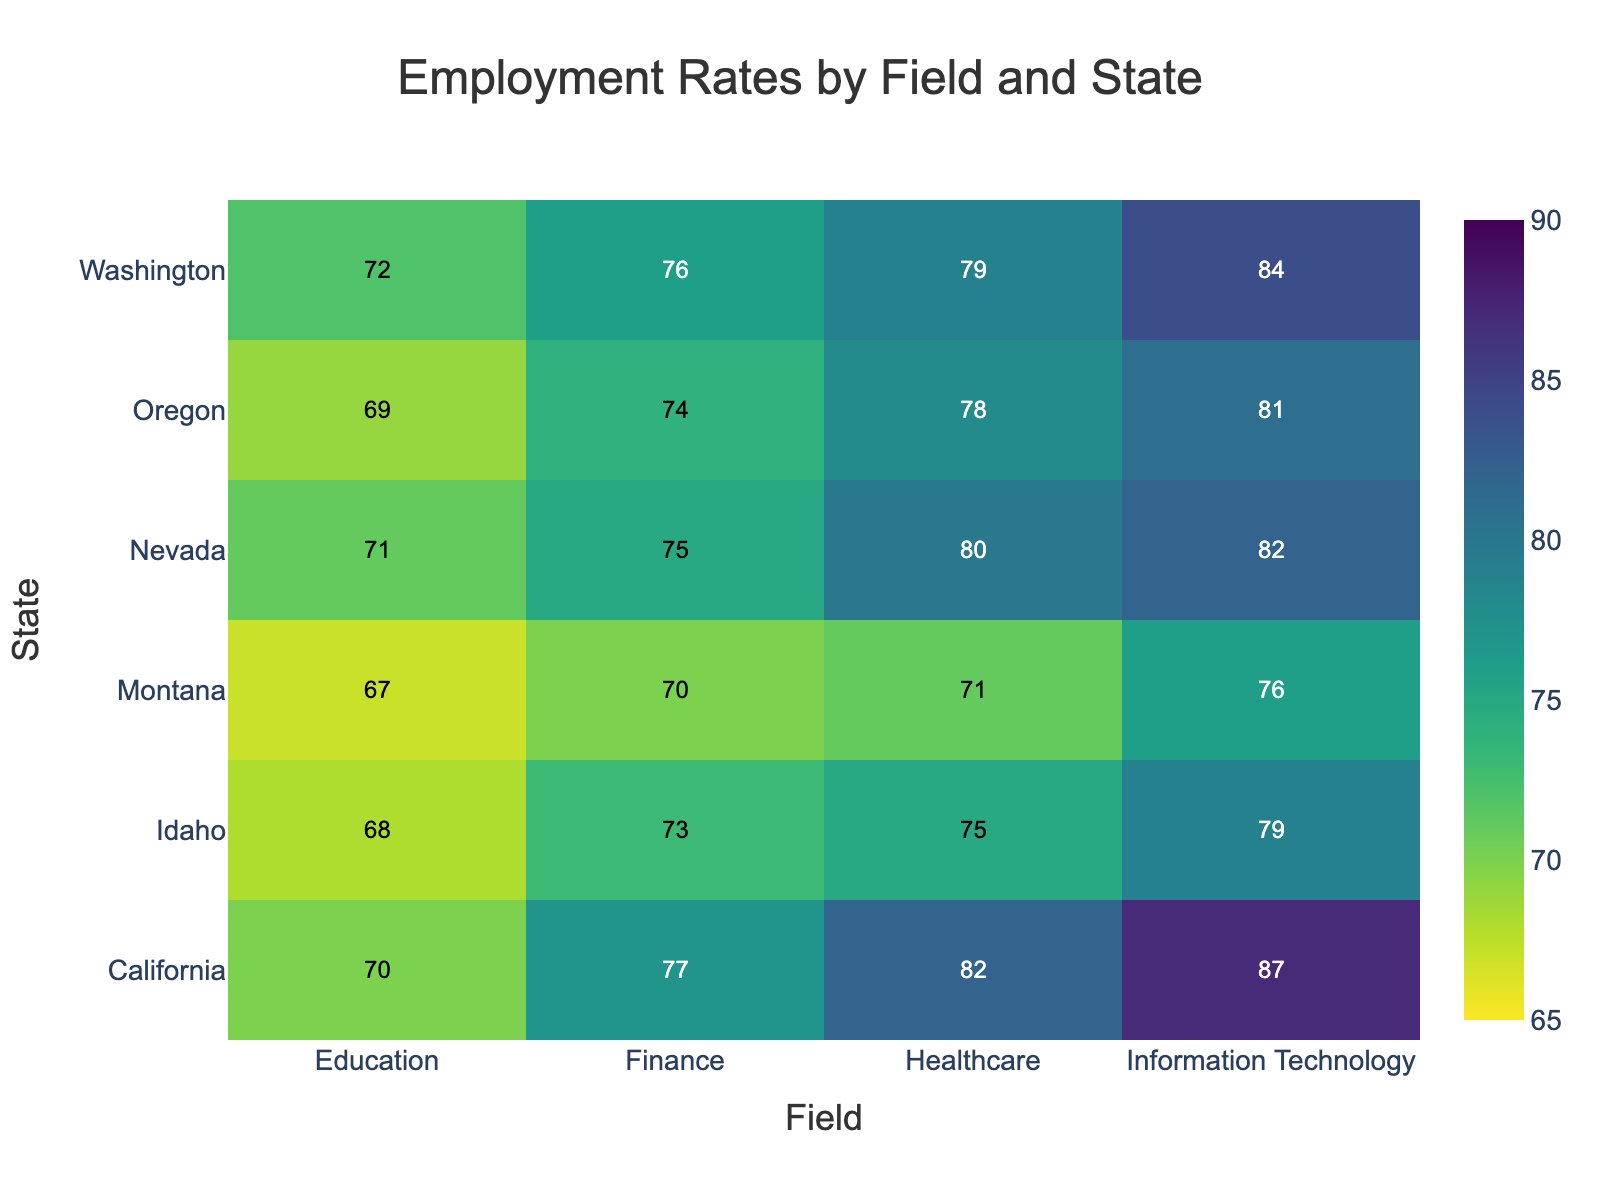What's the employment rate in Information Technology in Washington? Look for Washington on the y-axis and Information Technology on the x-axis. The cell where they intersect will give the employment rate.
Answer: 84% Which state has the highest employment rate in Healthcare? Compare the employment rates in Healthcare across all states. Find the highest rate.
Answer: California What is the difference in employment rates between Information Technology and Education in California? Identify the employment rates in California for Information Technology and Education. Subtract the employment rate of Education from that of Information Technology.
Answer: 17% What is the median employment rate for Education among all states? List out all the employment rates for Education. Sort them and find the median (the middle value). The values are 67, 68, 69, 70, 71, 72. Median is the average of the two middle values: (69+70)/2.
Answer: 69.5% Which field has the most consistent employment rates across all states? Evaluate the range (difference between the maximum and minimum employment rates) for each field across states. The field with the smallest range is the most consistent. Information Technology: range = 87-76 = 11 Healthcare: range = 82-71 = 11 Education: range = 72-67 = 5 Finance: range = 77-70 = 7
Answer: Education Are there any fields where all states have an employment rate above 70%? Check each field's employment rate across all states to see if they are all above 70%. Information Technology: All above 70% Healthcare: All above 70% Education: Montana and Idaho have values below 70% Finance: All above 70%
Answer: Information Technology, Healthcare, Finance Which state has the lowest employment rate in any field, and what is it? Scan through all employment rates in the heatmap to find the lowest value and its corresponding state and field.
Answer: Montana in Education, 67% Is the employment rate in Finance higher in Nevada or Idaho? Compare the employment rates in Finance for Nevada and Idaho directly from the heatmap.
Answer: Nevada What is the average employment rate in Information Technology across all states? List the employment rates for Information Technology across all states: 84, 81, 87, 79, 76, 82. Calculate the average by summing them up and dividing by the number of states. (84+81+87+79+76+82)/6 = 81.5
Answer: 81.5% 